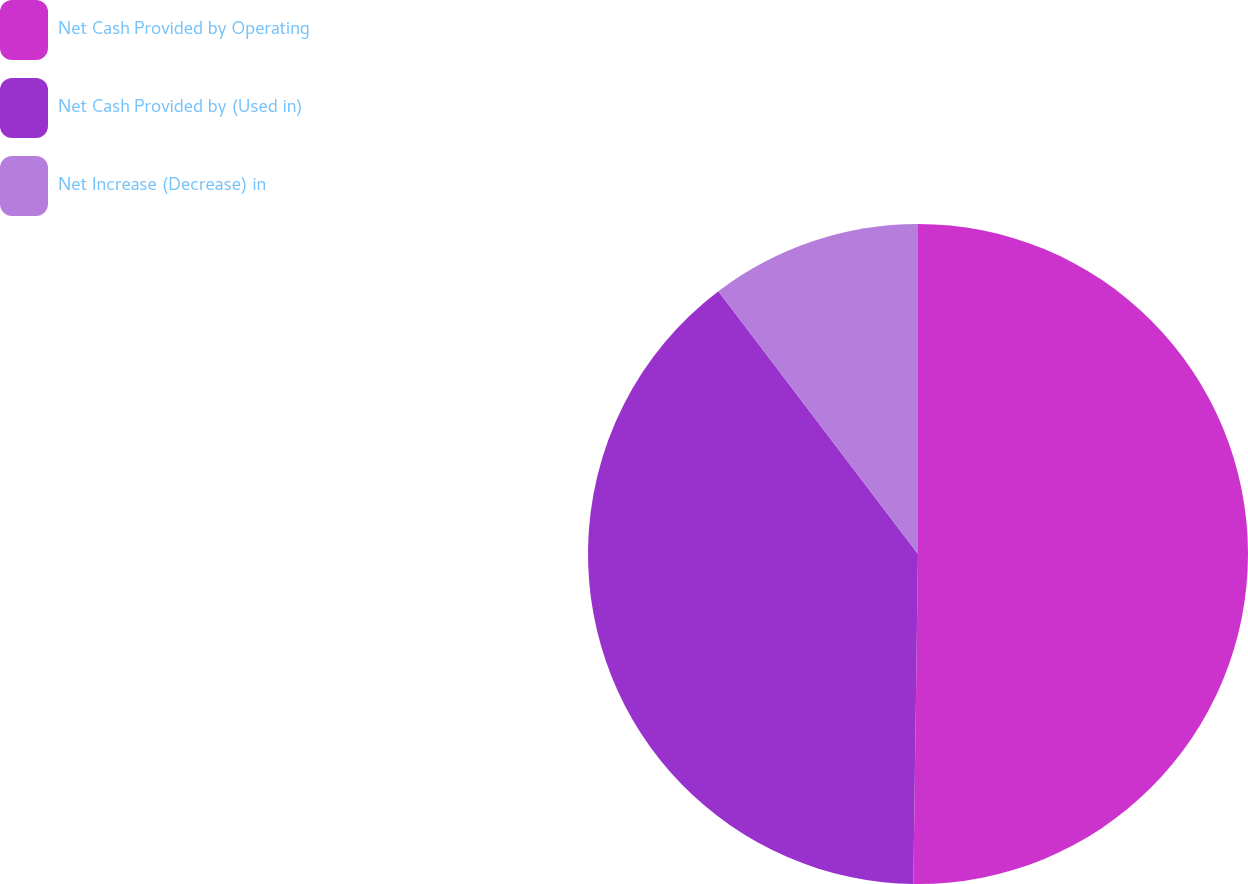Convert chart to OTSL. <chart><loc_0><loc_0><loc_500><loc_500><pie_chart><fcel>Net Cash Provided by Operating<fcel>Net Cash Provided by (Used in)<fcel>Net Increase (Decrease) in<nl><fcel>50.22%<fcel>39.43%<fcel>10.34%<nl></chart> 